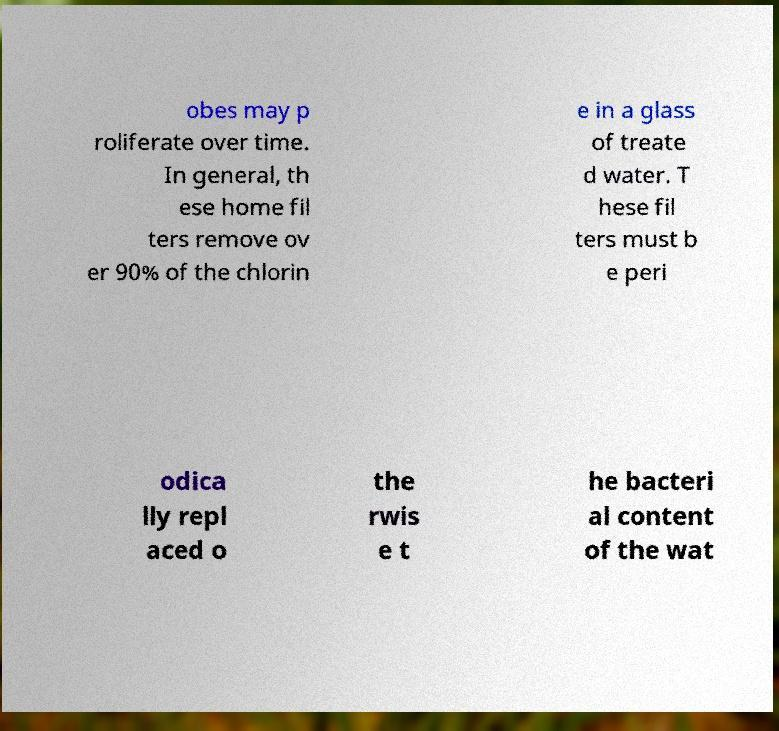Could you assist in decoding the text presented in this image and type it out clearly? obes may p roliferate over time. In general, th ese home fil ters remove ov er 90% of the chlorin e in a glass of treate d water. T hese fil ters must b e peri odica lly repl aced o the rwis e t he bacteri al content of the wat 